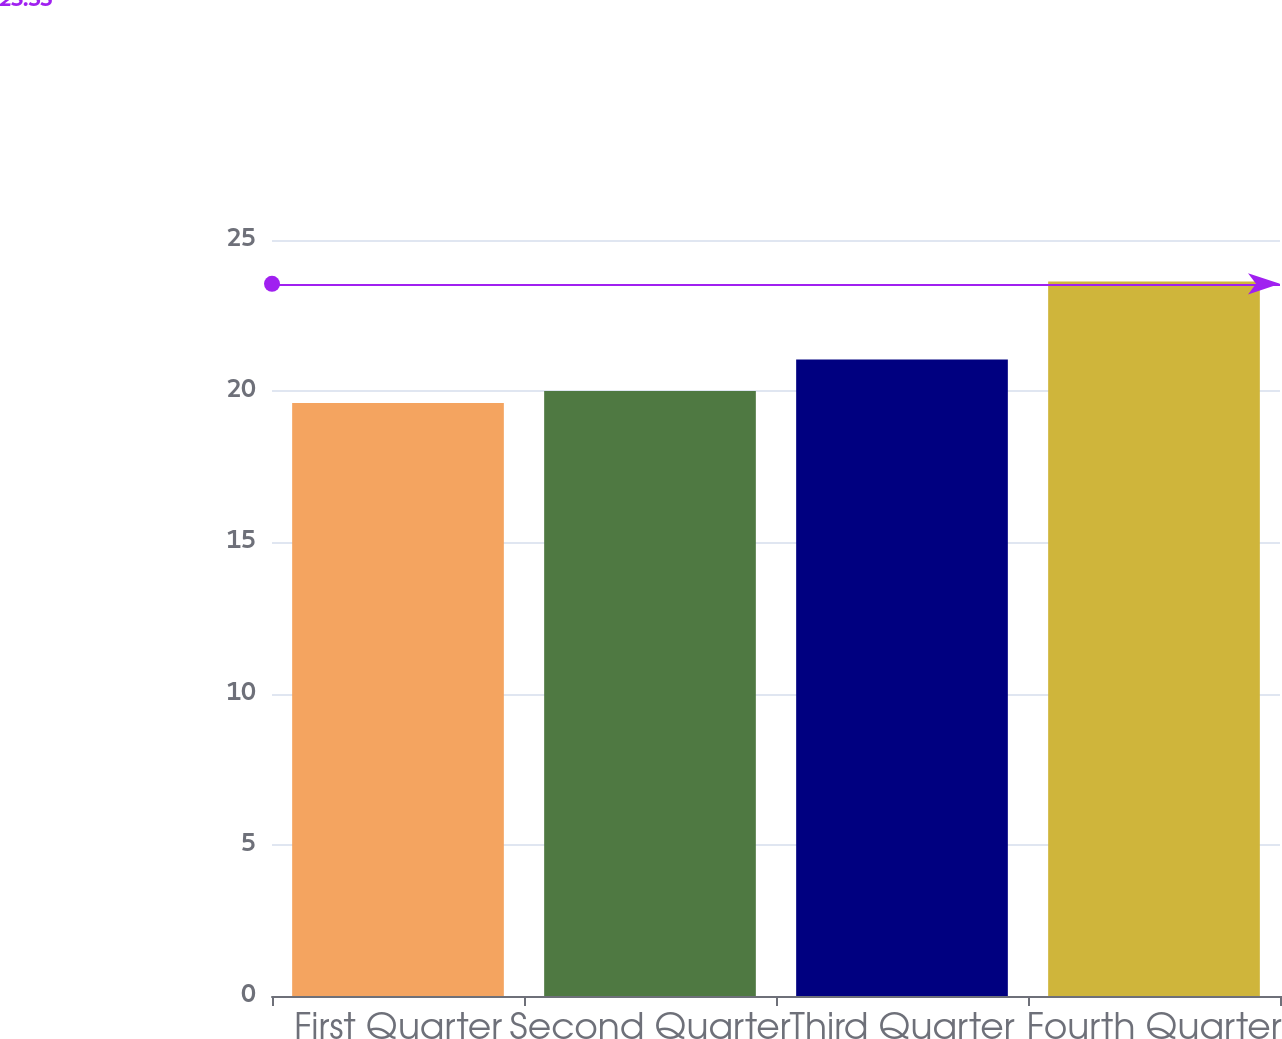Convert chart to OTSL. <chart><loc_0><loc_0><loc_500><loc_500><bar_chart><fcel>First Quarter<fcel>Second Quarter<fcel>Third Quarter<fcel>Fourth Quarter<nl><fcel>19.61<fcel>20.01<fcel>21.05<fcel>23.63<nl></chart> 